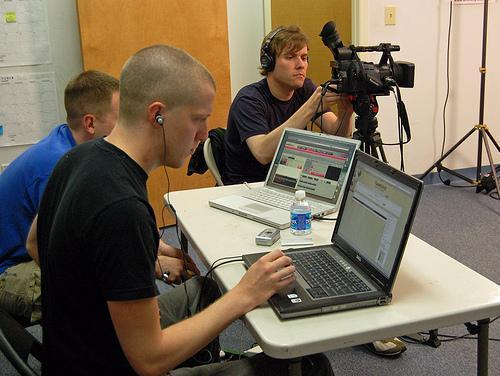Which one is doing silent work?
Choose the right answer from the provided options to respond to the question.
Options: None, middle, right, left. Middle. 